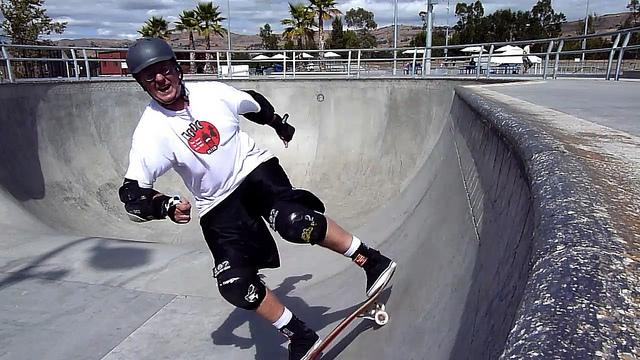Is it important to have safety gear on when skateboarding?
Give a very brief answer. Yes. Is he wearing a helmet?
Write a very short answer. Yes. Is this in a skate park?
Be succinct. Yes. 